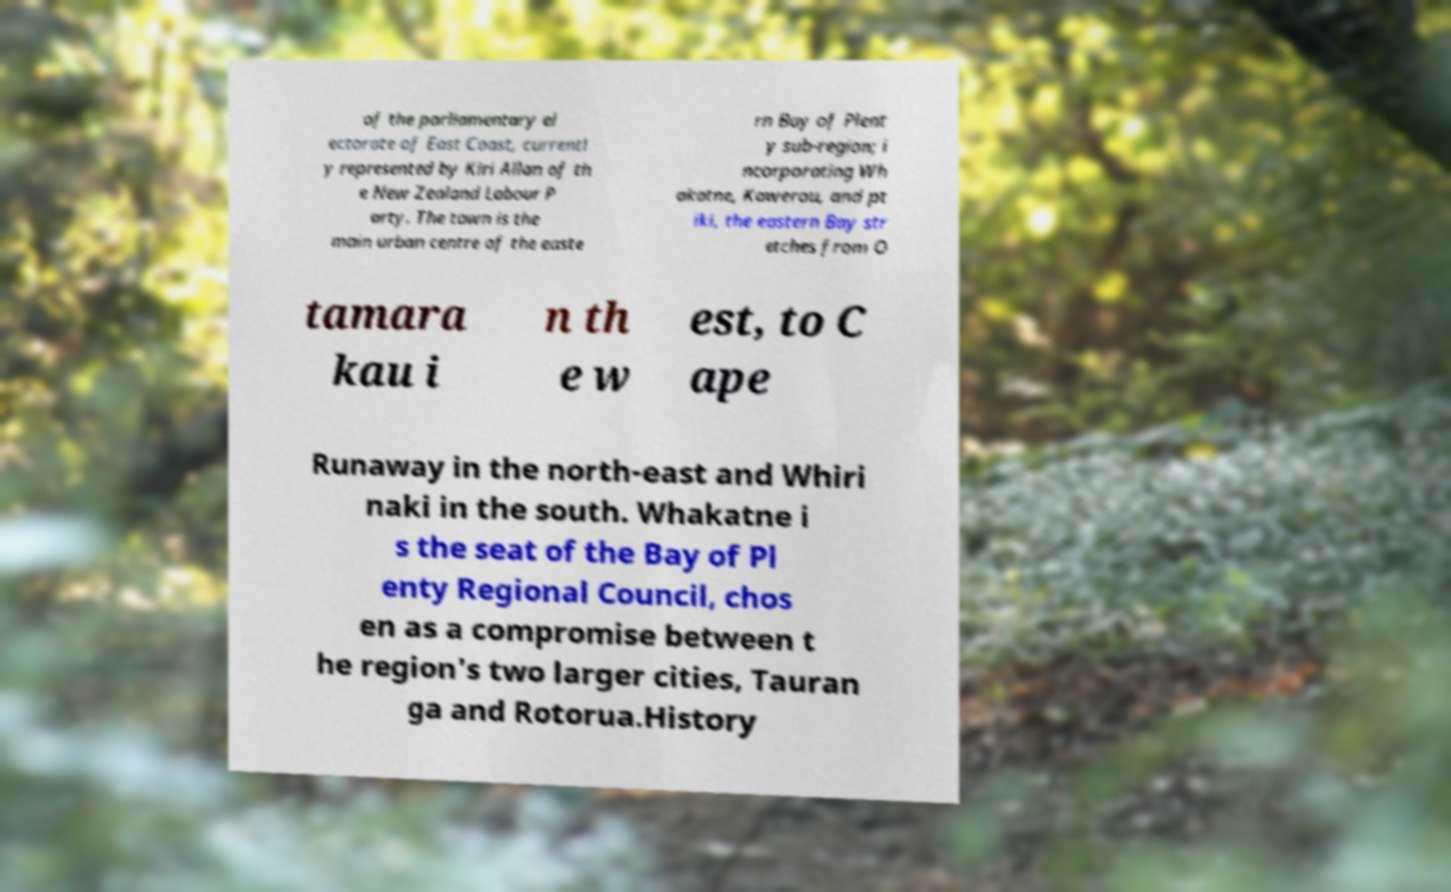What messages or text are displayed in this image? I need them in a readable, typed format. of the parliamentary el ectorate of East Coast, currentl y represented by Kiri Allan of th e New Zealand Labour P arty. The town is the main urban centre of the easte rn Bay of Plent y sub-region; i ncorporating Wh akatne, Kawerau, and pt iki, the eastern Bay str etches from O tamara kau i n th e w est, to C ape Runaway in the north-east and Whiri naki in the south. Whakatne i s the seat of the Bay of Pl enty Regional Council, chos en as a compromise between t he region's two larger cities, Tauran ga and Rotorua.History 